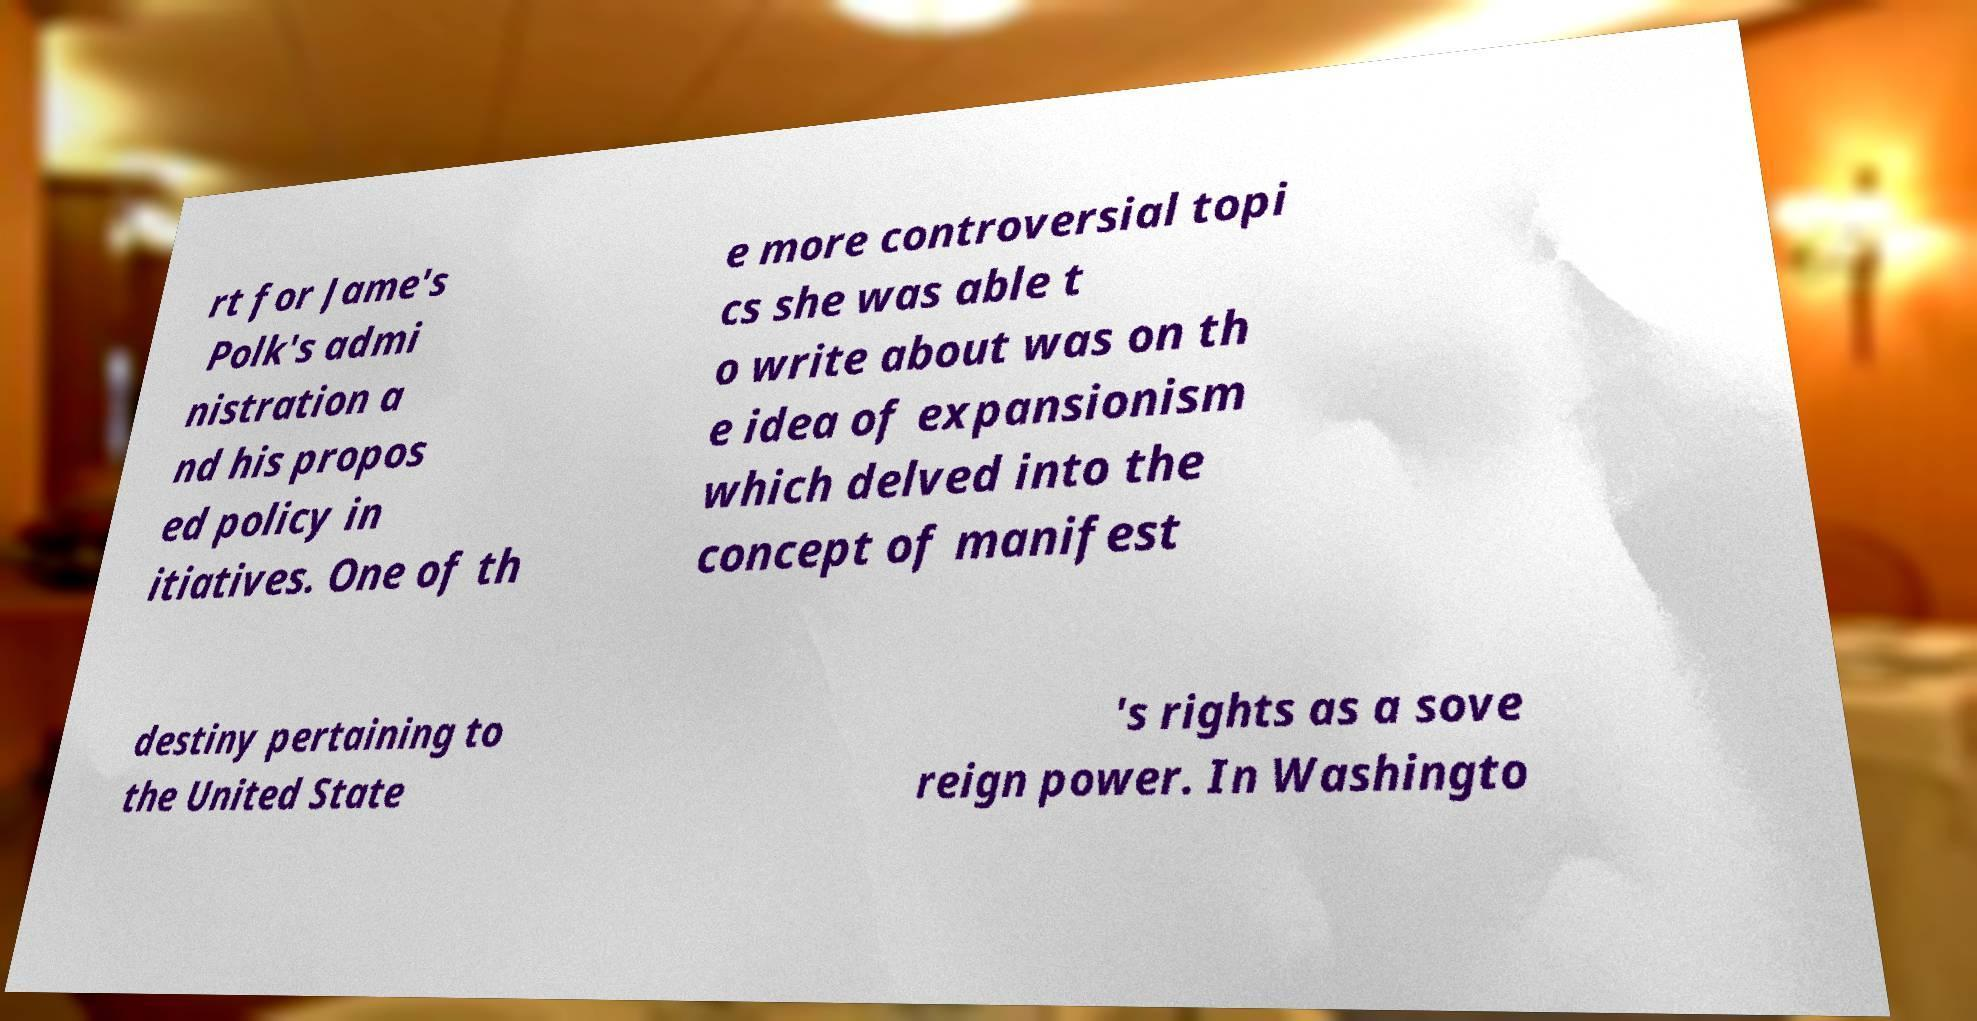There's text embedded in this image that I need extracted. Can you transcribe it verbatim? rt for Jame's Polk's admi nistration a nd his propos ed policy in itiatives. One of th e more controversial topi cs she was able t o write about was on th e idea of expansionism which delved into the concept of manifest destiny pertaining to the United State 's rights as a sove reign power. In Washingto 